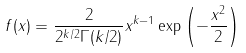<formula> <loc_0><loc_0><loc_500><loc_500>f ( x ) = { \frac { 2 } { 2 ^ { k / 2 } \Gamma ( k / 2 ) } } x ^ { k - 1 } \exp \left ( - { \frac { x ^ { 2 } } { 2 } } \right )</formula> 